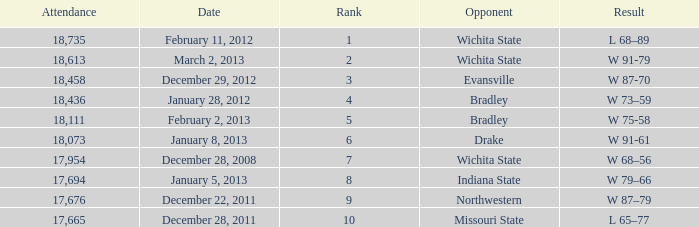What's the placement for february 11, 2012 with less than 18,735 attendees? None. 